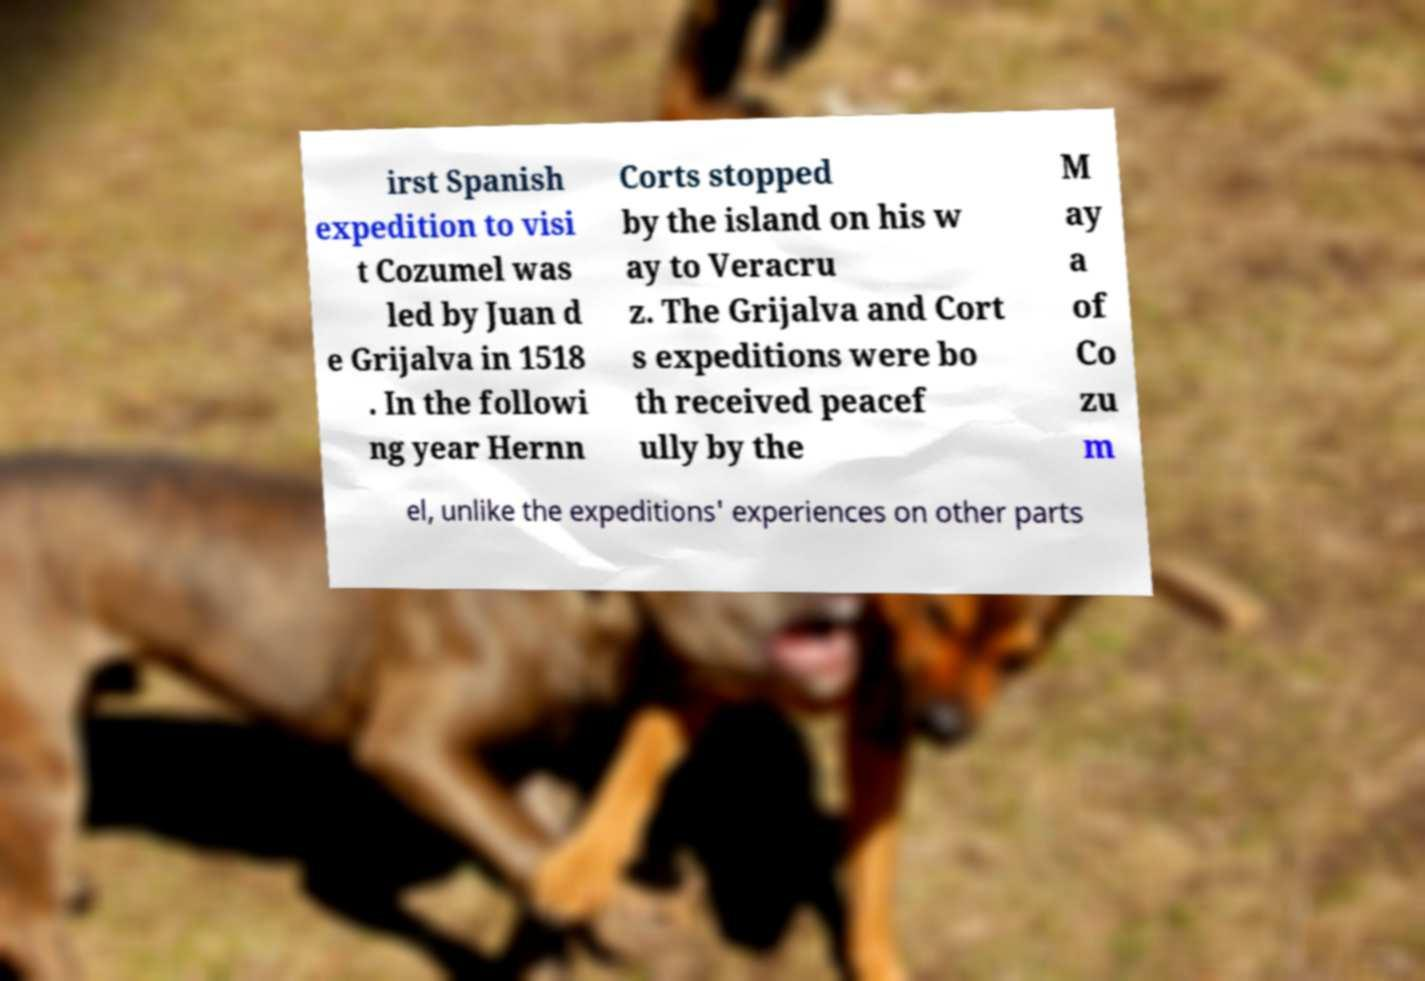Can you read and provide the text displayed in the image?This photo seems to have some interesting text. Can you extract and type it out for me? irst Spanish expedition to visi t Cozumel was led by Juan d e Grijalva in 1518 . In the followi ng year Hernn Corts stopped by the island on his w ay to Veracru z. The Grijalva and Cort s expeditions were bo th received peacef ully by the M ay a of Co zu m el, unlike the expeditions' experiences on other parts 